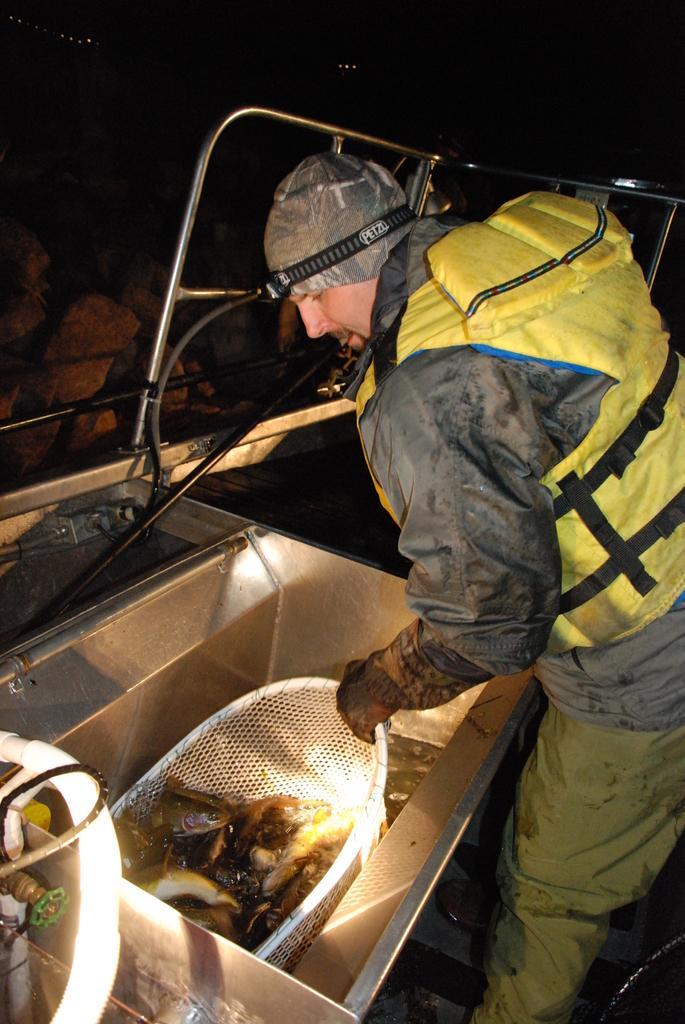Could you give a brief overview of what you see in this image? In this image I can see a man is standing and I can see he is wearing jacket, glove, pant and a cap. I can see he is holding a basket and in it I can see few things. 